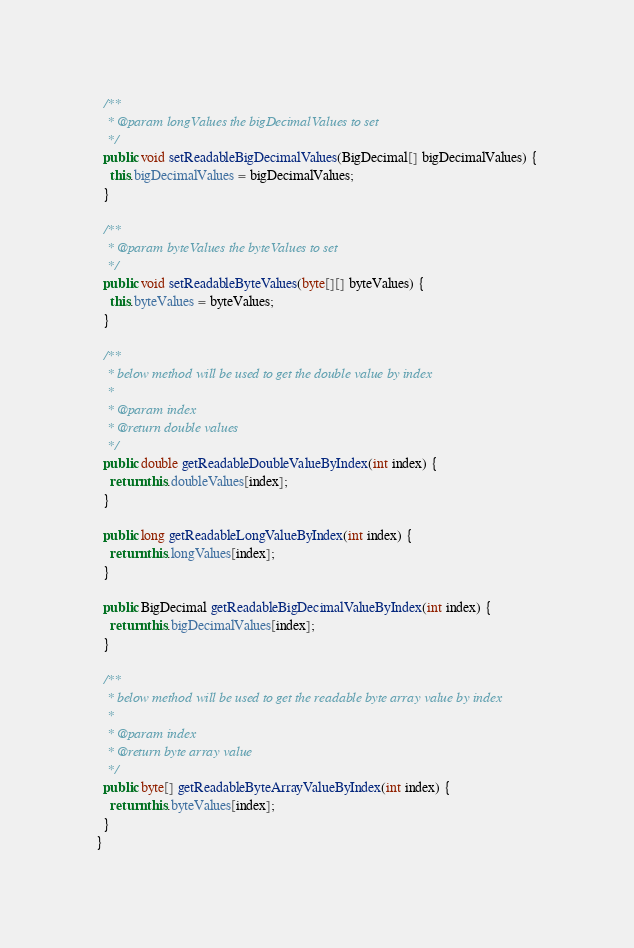<code> <loc_0><loc_0><loc_500><loc_500><_Java_>
  /**
   * @param longValues the bigDecimalValues to set
   */
  public void setReadableBigDecimalValues(BigDecimal[] bigDecimalValues) {
    this.bigDecimalValues = bigDecimalValues;
  }

  /**
   * @param byteValues the byteValues to set
   */
  public void setReadableByteValues(byte[][] byteValues) {
    this.byteValues = byteValues;
  }

  /**
   * below method will be used to get the double value by index
   *
   * @param index
   * @return double values
   */
  public double getReadableDoubleValueByIndex(int index) {
    return this.doubleValues[index];
  }

  public long getReadableLongValueByIndex(int index) {
    return this.longValues[index];
  }

  public BigDecimal getReadableBigDecimalValueByIndex(int index) {
    return this.bigDecimalValues[index];
  }

  /**
   * below method will be used to get the readable byte array value by index
   *
   * @param index
   * @return byte array value
   */
  public byte[] getReadableByteArrayValueByIndex(int index) {
    return this.byteValues[index];
  }
}
</code> 